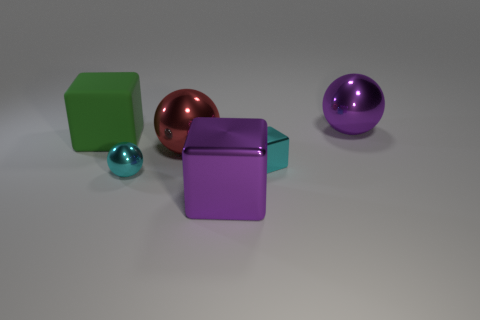Add 1 big brown rubber spheres. How many big brown rubber spheres exist? 1 Add 3 big purple matte cylinders. How many objects exist? 9 Subtract all purple cubes. How many cubes are left? 2 Subtract all small cyan metal cubes. How many cubes are left? 2 Subtract 1 purple spheres. How many objects are left? 5 Subtract 2 cubes. How many cubes are left? 1 Subtract all gray cubes. Subtract all blue spheres. How many cubes are left? 3 Subtract all brown cubes. How many gray balls are left? 0 Subtract all large green things. Subtract all red objects. How many objects are left? 4 Add 4 large things. How many large things are left? 8 